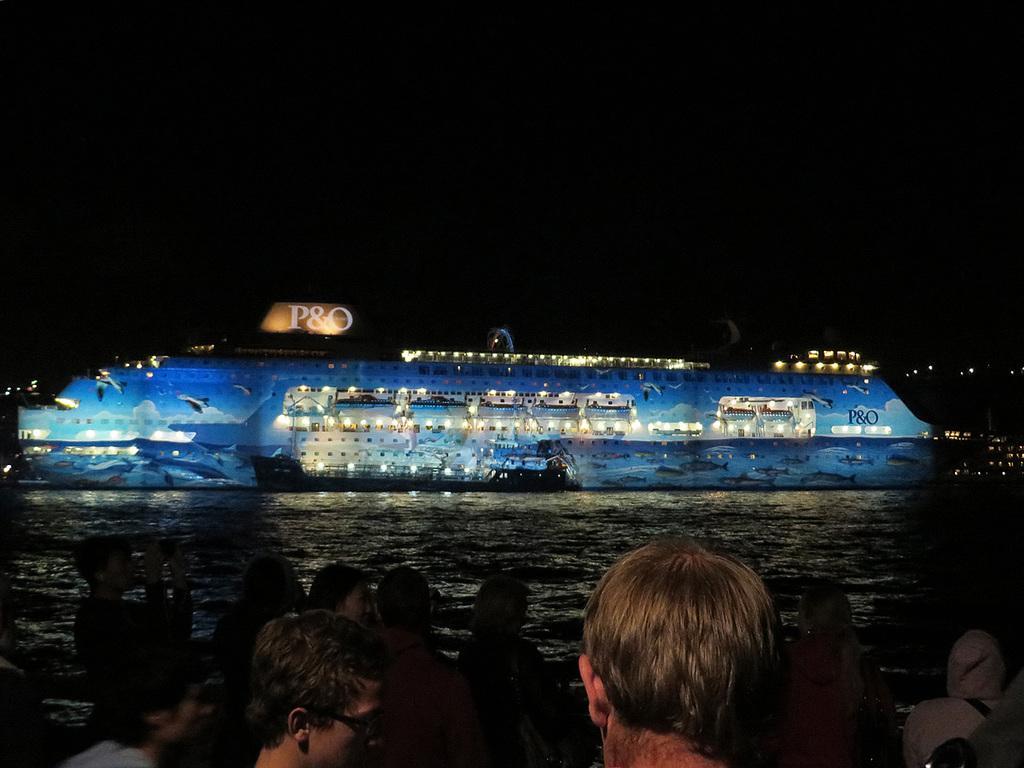Describe this image in one or two sentences. In this picture we can see a group of people standing on the path and in front of the people there is a boat on the water. Behind the boat there is a dark background. 